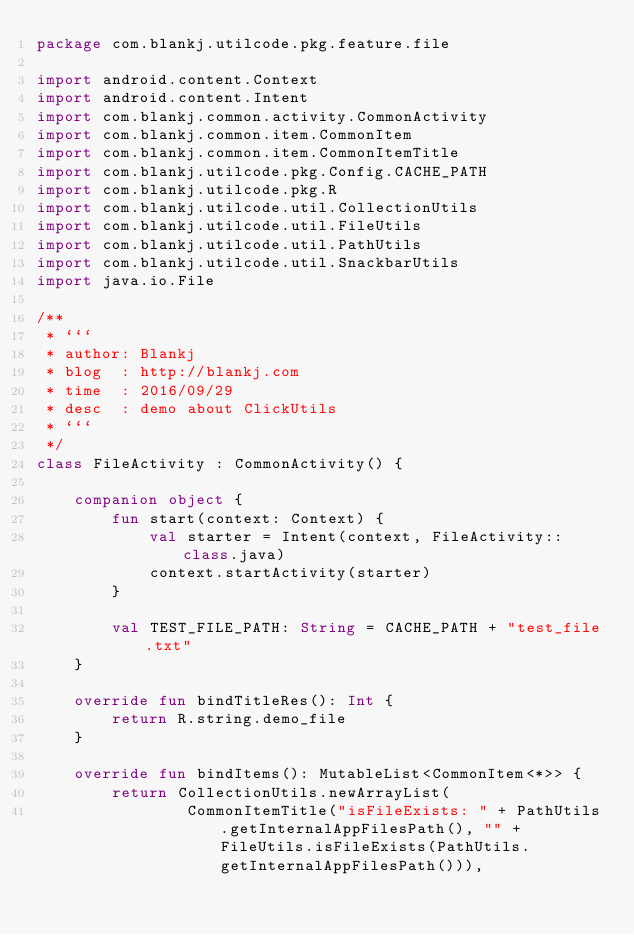Convert code to text. <code><loc_0><loc_0><loc_500><loc_500><_Kotlin_>package com.blankj.utilcode.pkg.feature.file

import android.content.Context
import android.content.Intent
import com.blankj.common.activity.CommonActivity
import com.blankj.common.item.CommonItem
import com.blankj.common.item.CommonItemTitle
import com.blankj.utilcode.pkg.Config.CACHE_PATH
import com.blankj.utilcode.pkg.R
import com.blankj.utilcode.util.CollectionUtils
import com.blankj.utilcode.util.FileUtils
import com.blankj.utilcode.util.PathUtils
import com.blankj.utilcode.util.SnackbarUtils
import java.io.File

/**
 * ```
 * author: Blankj
 * blog  : http://blankj.com
 * time  : 2016/09/29
 * desc  : demo about ClickUtils
 * ```
 */
class FileActivity : CommonActivity() {

    companion object {
        fun start(context: Context) {
            val starter = Intent(context, FileActivity::class.java)
            context.startActivity(starter)
        }

        val TEST_FILE_PATH: String = CACHE_PATH + "test_file.txt"
    }

    override fun bindTitleRes(): Int {
        return R.string.demo_file
    }

    override fun bindItems(): MutableList<CommonItem<*>> {
        return CollectionUtils.newArrayList(
                CommonItemTitle("isFileExists: " + PathUtils.getInternalAppFilesPath(), "" + FileUtils.isFileExists(PathUtils.getInternalAppFilesPath())),</code> 